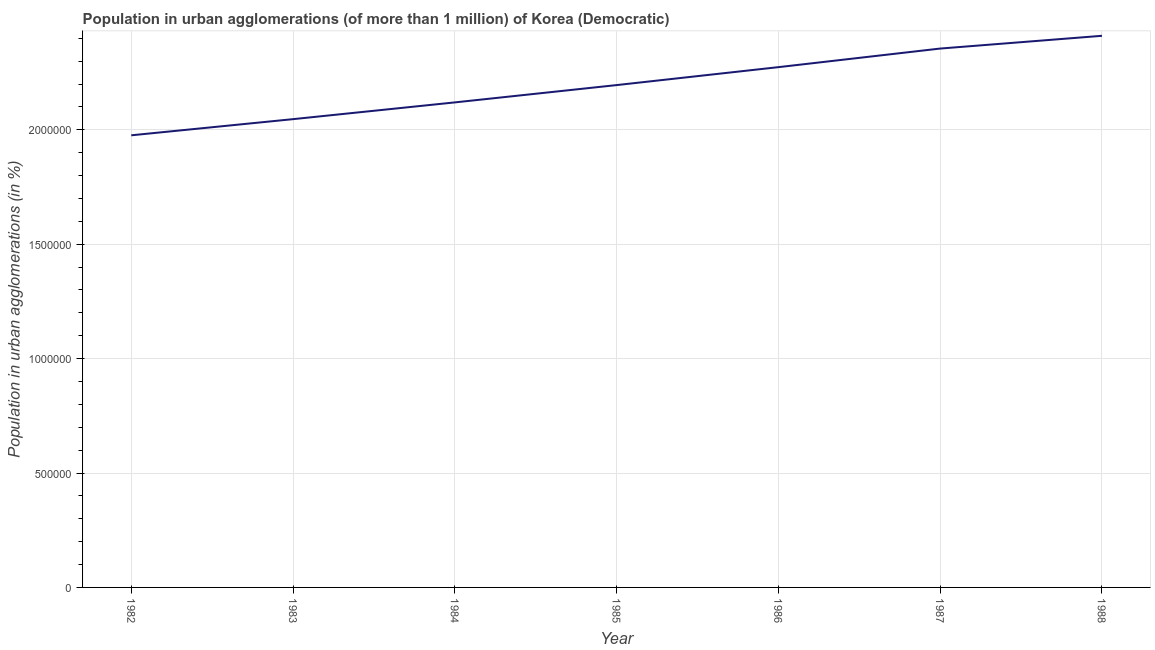What is the population in urban agglomerations in 1982?
Make the answer very short. 1.98e+06. Across all years, what is the maximum population in urban agglomerations?
Offer a very short reply. 2.41e+06. Across all years, what is the minimum population in urban agglomerations?
Provide a short and direct response. 1.98e+06. What is the sum of the population in urban agglomerations?
Your answer should be compact. 1.54e+07. What is the difference between the population in urban agglomerations in 1983 and 1986?
Ensure brevity in your answer.  -2.27e+05. What is the average population in urban agglomerations per year?
Ensure brevity in your answer.  2.20e+06. What is the median population in urban agglomerations?
Your response must be concise. 2.20e+06. In how many years, is the population in urban agglomerations greater than 700000 %?
Your response must be concise. 7. What is the ratio of the population in urban agglomerations in 1982 to that in 1985?
Make the answer very short. 0.9. Is the population in urban agglomerations in 1982 less than that in 1987?
Make the answer very short. Yes. Is the difference between the population in urban agglomerations in 1985 and 1986 greater than the difference between any two years?
Your answer should be compact. No. What is the difference between the highest and the second highest population in urban agglomerations?
Provide a succinct answer. 5.57e+04. What is the difference between the highest and the lowest population in urban agglomerations?
Your answer should be compact. 4.35e+05. How many years are there in the graph?
Keep it short and to the point. 7. What is the difference between two consecutive major ticks on the Y-axis?
Provide a succinct answer. 5.00e+05. Are the values on the major ticks of Y-axis written in scientific E-notation?
Provide a succinct answer. No. Does the graph contain any zero values?
Your answer should be very brief. No. What is the title of the graph?
Your response must be concise. Population in urban agglomerations (of more than 1 million) of Korea (Democratic). What is the label or title of the Y-axis?
Provide a short and direct response. Population in urban agglomerations (in %). What is the Population in urban agglomerations (in %) of 1982?
Your response must be concise. 1.98e+06. What is the Population in urban agglomerations (in %) in 1983?
Provide a succinct answer. 2.05e+06. What is the Population in urban agglomerations (in %) of 1984?
Your answer should be very brief. 2.12e+06. What is the Population in urban agglomerations (in %) in 1985?
Your answer should be very brief. 2.20e+06. What is the Population in urban agglomerations (in %) of 1986?
Offer a very short reply. 2.27e+06. What is the Population in urban agglomerations (in %) in 1987?
Provide a short and direct response. 2.36e+06. What is the Population in urban agglomerations (in %) of 1988?
Ensure brevity in your answer.  2.41e+06. What is the difference between the Population in urban agglomerations (in %) in 1982 and 1983?
Ensure brevity in your answer.  -7.06e+04. What is the difference between the Population in urban agglomerations (in %) in 1982 and 1984?
Ensure brevity in your answer.  -1.44e+05. What is the difference between the Population in urban agglomerations (in %) in 1982 and 1985?
Ensure brevity in your answer.  -2.19e+05. What is the difference between the Population in urban agglomerations (in %) in 1982 and 1986?
Offer a terse response. -2.98e+05. What is the difference between the Population in urban agglomerations (in %) in 1982 and 1987?
Keep it short and to the point. -3.79e+05. What is the difference between the Population in urban agglomerations (in %) in 1982 and 1988?
Ensure brevity in your answer.  -4.35e+05. What is the difference between the Population in urban agglomerations (in %) in 1983 and 1984?
Your answer should be very brief. -7.32e+04. What is the difference between the Population in urban agglomerations (in %) in 1983 and 1985?
Provide a short and direct response. -1.49e+05. What is the difference between the Population in urban agglomerations (in %) in 1983 and 1986?
Provide a short and direct response. -2.27e+05. What is the difference between the Population in urban agglomerations (in %) in 1983 and 1987?
Keep it short and to the point. -3.09e+05. What is the difference between the Population in urban agglomerations (in %) in 1983 and 1988?
Make the answer very short. -3.64e+05. What is the difference between the Population in urban agglomerations (in %) in 1984 and 1985?
Your answer should be very brief. -7.56e+04. What is the difference between the Population in urban agglomerations (in %) in 1984 and 1986?
Your answer should be very brief. -1.54e+05. What is the difference between the Population in urban agglomerations (in %) in 1984 and 1987?
Your response must be concise. -2.35e+05. What is the difference between the Population in urban agglomerations (in %) in 1984 and 1988?
Provide a short and direct response. -2.91e+05. What is the difference between the Population in urban agglomerations (in %) in 1985 and 1986?
Give a very brief answer. -7.84e+04. What is the difference between the Population in urban agglomerations (in %) in 1985 and 1987?
Keep it short and to the point. -1.60e+05. What is the difference between the Population in urban agglomerations (in %) in 1985 and 1988?
Keep it short and to the point. -2.15e+05. What is the difference between the Population in urban agglomerations (in %) in 1986 and 1987?
Ensure brevity in your answer.  -8.12e+04. What is the difference between the Population in urban agglomerations (in %) in 1986 and 1988?
Give a very brief answer. -1.37e+05. What is the difference between the Population in urban agglomerations (in %) in 1987 and 1988?
Offer a terse response. -5.57e+04. What is the ratio of the Population in urban agglomerations (in %) in 1982 to that in 1984?
Ensure brevity in your answer.  0.93. What is the ratio of the Population in urban agglomerations (in %) in 1982 to that in 1986?
Provide a succinct answer. 0.87. What is the ratio of the Population in urban agglomerations (in %) in 1982 to that in 1987?
Make the answer very short. 0.84. What is the ratio of the Population in urban agglomerations (in %) in 1982 to that in 1988?
Your response must be concise. 0.82. What is the ratio of the Population in urban agglomerations (in %) in 1983 to that in 1984?
Offer a very short reply. 0.96. What is the ratio of the Population in urban agglomerations (in %) in 1983 to that in 1985?
Make the answer very short. 0.93. What is the ratio of the Population in urban agglomerations (in %) in 1983 to that in 1986?
Provide a succinct answer. 0.9. What is the ratio of the Population in urban agglomerations (in %) in 1983 to that in 1987?
Provide a short and direct response. 0.87. What is the ratio of the Population in urban agglomerations (in %) in 1983 to that in 1988?
Provide a short and direct response. 0.85. What is the ratio of the Population in urban agglomerations (in %) in 1984 to that in 1986?
Your answer should be compact. 0.93. What is the ratio of the Population in urban agglomerations (in %) in 1984 to that in 1988?
Give a very brief answer. 0.88. What is the ratio of the Population in urban agglomerations (in %) in 1985 to that in 1986?
Keep it short and to the point. 0.97. What is the ratio of the Population in urban agglomerations (in %) in 1985 to that in 1987?
Provide a succinct answer. 0.93. What is the ratio of the Population in urban agglomerations (in %) in 1985 to that in 1988?
Ensure brevity in your answer.  0.91. What is the ratio of the Population in urban agglomerations (in %) in 1986 to that in 1987?
Provide a short and direct response. 0.97. What is the ratio of the Population in urban agglomerations (in %) in 1986 to that in 1988?
Provide a short and direct response. 0.94. 